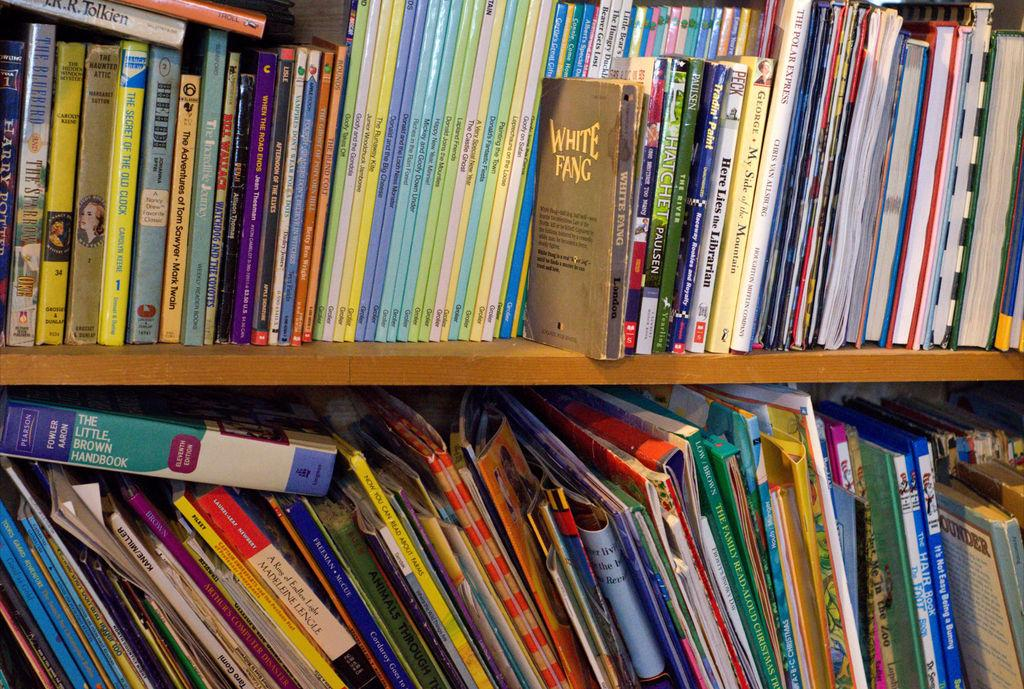<image>
Create a compact narrative representing the image presented. the words white fang are on a book 